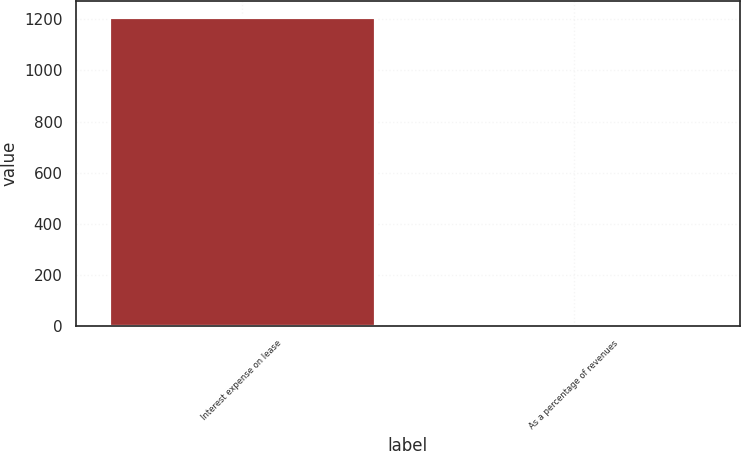<chart> <loc_0><loc_0><loc_500><loc_500><bar_chart><fcel>Interest expense on lease<fcel>As a percentage of revenues<nl><fcel>1210<fcel>0.1<nl></chart> 